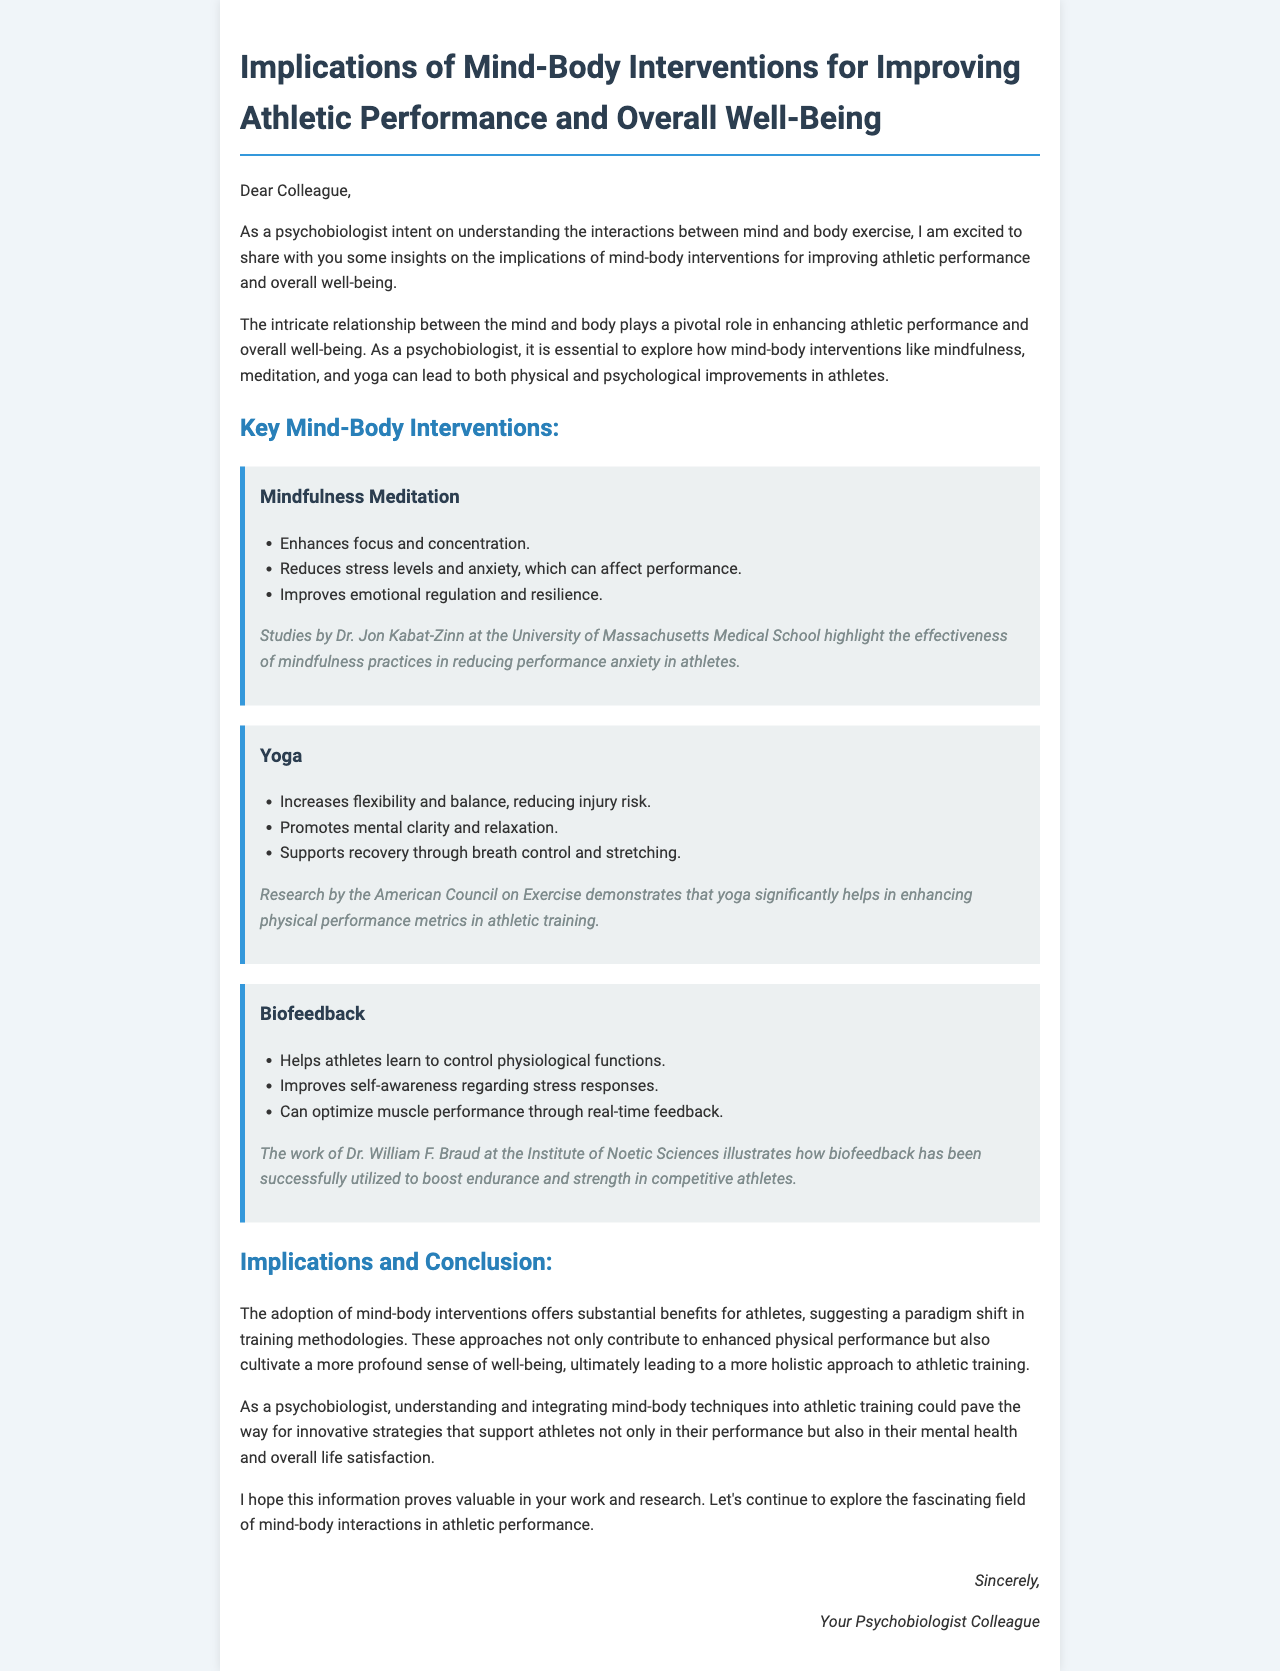What are the key mind-body interventions discussed? The letter specifically lists mindfulness meditation, yoga, and biofeedback as key interventions.
Answer: mindfulness meditation, yoga, biofeedback Who conducted studies on mindfulness practices in athletes? The text mentions Dr. Jon Kabat-Zinn in relation to mindfulness practices and performance anxiety in athletes.
Answer: Dr. Jon Kabat-Zinn What does yoga primarily promote according to the document? The letter states that yoga promotes mental clarity and relaxation among other benefits.
Answer: mental clarity and relaxation What is one benefit of biofeedback mentioned? The document highlights that biofeedback helps athletes learn to control physiological functions.
Answer: control physiological functions What is the significance of mind-body interventions in athletic training? The letter mentions a paradigm shift towards a more holistic approach to athletic training, emphasizing mental health and performance.
Answer: paradigm shift What does the author hope the information will prove? The author expresses a hope that the information will be valuable in the recipient's work and research.
Answer: valuable What is the primary focus of the letter? The letter focuses on the implications of mind-body interventions for athletic performance and well-being.
Answer: implications of mind-body interventions What type of improvements do mind-body interventions lead to? The document indicates that both physical and psychological improvements can result from these interventions.
Answer: physical and psychological improvements Who is the author of the letter? The conclusion of the letter states that it is from "Your Psychobiologist Colleague."
Answer: Your Psychobiologist Colleague 